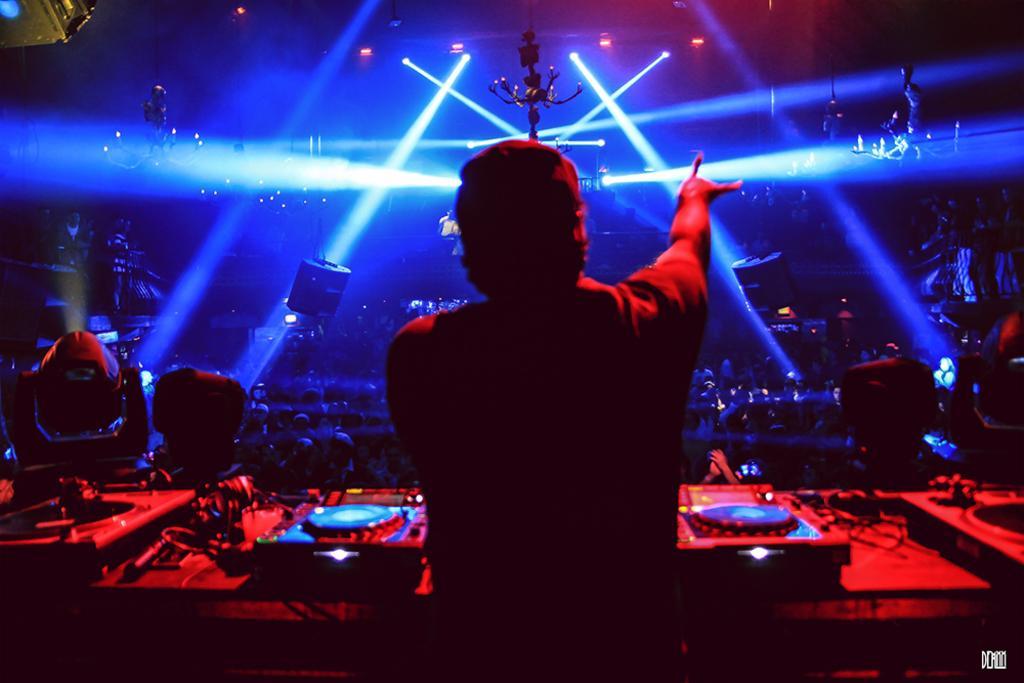In one or two sentences, can you explain what this image depicts? In this image, we can see a person in front of the musical equipment. There are some persons in the middle of the image. There are lights at the top of the image. 